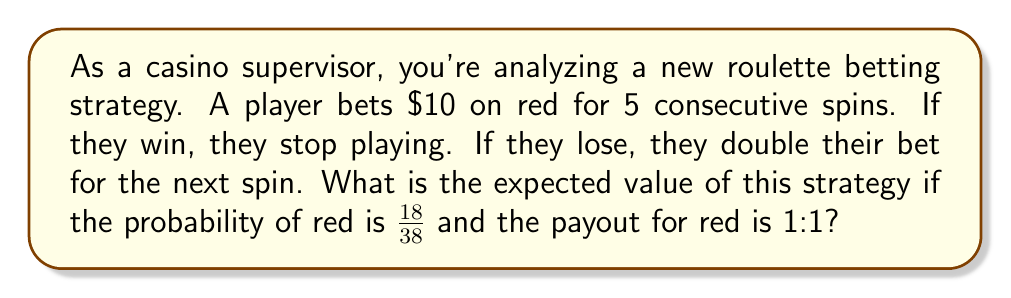Teach me how to tackle this problem. Let's approach this step-by-step:

1) First, let's calculate the probability of each outcome:

   P(win on 1st spin) = $\frac{18}{38}$
   P(win on 2nd spin) = $\frac{20}{38} \cdot \frac{18}{38}$
   P(win on 3rd spin) = $(\frac{20}{38})^2 \cdot \frac{18}{38}$
   P(win on 4th spin) = $(\frac{20}{38})^3 \cdot \frac{18}{38}$
   P(win on 5th spin) = $(\frac{20}{38})^4 \cdot \frac{18}{38}$
   P(lose all 5 spins) = $(\frac{20}{38})^5$

2) Now, let's calculate the net gain/loss for each outcome:

   Win on 1st spin: $10
   Win on 2nd spin: $-10 + 20 = 10$
   Win on 3rd spin: $-10 - 20 + 40 = 10$
   Win on 4th spin: $-10 - 20 - 40 + 80 = 10$
   Win on 5th spin: $-10 - 20 - 40 - 80 + 160 = 10$
   Lose all 5 spins: $-10 - 20 - 40 - 80 - 160 = -310$

3) The expected value is the sum of each outcome multiplied by its probability:

   $$E = 10 \cdot \frac{18}{38} + 10 \cdot \frac{20}{38} \cdot \frac{18}{38} + 10 \cdot (\frac{20}{38})^2 \cdot \frac{18}{38} + 10 \cdot (\frac{20}{38})^3 \cdot \frac{18}{38} + 10 \cdot (\frac{20}{38})^4 \cdot \frac{18}{38} - 310 \cdot (\frac{20}{38})^5$$

4) Simplifying:

   $$E = 10 \cdot \frac{18}{38} \cdot (1 + \frac{20}{38} + (\frac{20}{38})^2 + (\frac{20}{38})^3 + (\frac{20}{38})^4) - 310 \cdot (\frac{20}{38})^5$$

5) This simplifies to approximately -$5.26.
Answer: $-5.26 